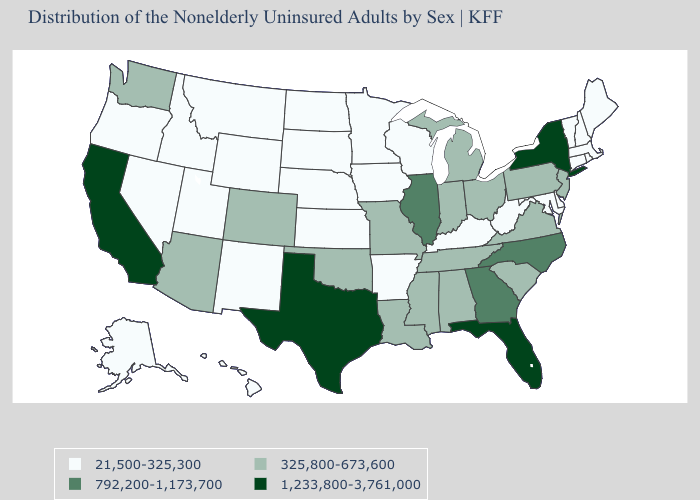How many symbols are there in the legend?
Quick response, please. 4. What is the lowest value in the Northeast?
Quick response, please. 21,500-325,300. What is the value of New Hampshire?
Be succinct. 21,500-325,300. Among the states that border Illinois , does Missouri have the highest value?
Keep it brief. Yes. Name the states that have a value in the range 21,500-325,300?
Give a very brief answer. Alaska, Arkansas, Connecticut, Delaware, Hawaii, Idaho, Iowa, Kansas, Kentucky, Maine, Maryland, Massachusetts, Minnesota, Montana, Nebraska, Nevada, New Hampshire, New Mexico, North Dakota, Oregon, Rhode Island, South Dakota, Utah, Vermont, West Virginia, Wisconsin, Wyoming. Name the states that have a value in the range 792,200-1,173,700?
Keep it brief. Georgia, Illinois, North Carolina. Name the states that have a value in the range 792,200-1,173,700?
Be succinct. Georgia, Illinois, North Carolina. Does the map have missing data?
Short answer required. No. Does Maine have the highest value in the Northeast?
Be succinct. No. Name the states that have a value in the range 1,233,800-3,761,000?
Write a very short answer. California, Florida, New York, Texas. What is the value of Ohio?
Give a very brief answer. 325,800-673,600. Name the states that have a value in the range 325,800-673,600?
Be succinct. Alabama, Arizona, Colorado, Indiana, Louisiana, Michigan, Mississippi, Missouri, New Jersey, Ohio, Oklahoma, Pennsylvania, South Carolina, Tennessee, Virginia, Washington. What is the value of Wyoming?
Give a very brief answer. 21,500-325,300. Name the states that have a value in the range 1,233,800-3,761,000?
Give a very brief answer. California, Florida, New York, Texas. 